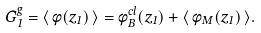Convert formula to latex. <formula><loc_0><loc_0><loc_500><loc_500>G _ { 1 } ^ { g } = \langle \, \phi ( z _ { 1 } ) \, \rangle = \phi _ { B } ^ { c l } ( z _ { 1 } ) + \langle \, \phi _ { M } ( z _ { 1 } ) \, \rangle .</formula> 